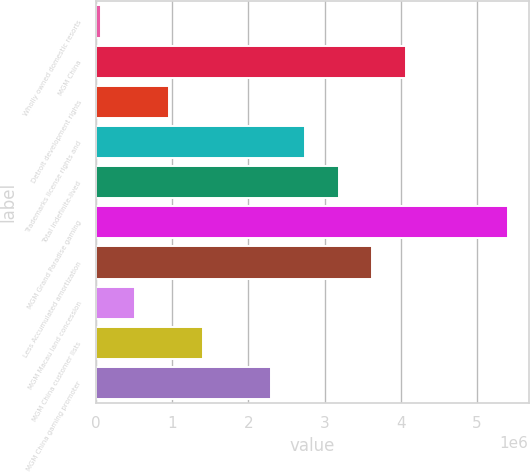<chart> <loc_0><loc_0><loc_500><loc_500><bar_chart><fcel>Wholly owned domestic resorts<fcel>MGM China<fcel>Detroit development rights<fcel>Trademarks license rights and<fcel>Total indefinite-lived<fcel>MGM Grand Paradise gaming<fcel>Less Accumulated amortization<fcel>MGM Macau land concession<fcel>MGM China customer lists<fcel>MGM China gaming promoter<nl><fcel>70975<fcel>4.07138e+06<fcel>959953<fcel>2.73791e+06<fcel>3.1824e+06<fcel>5.40485e+06<fcel>3.62689e+06<fcel>515464<fcel>1.40444e+06<fcel>2.29342e+06<nl></chart> 